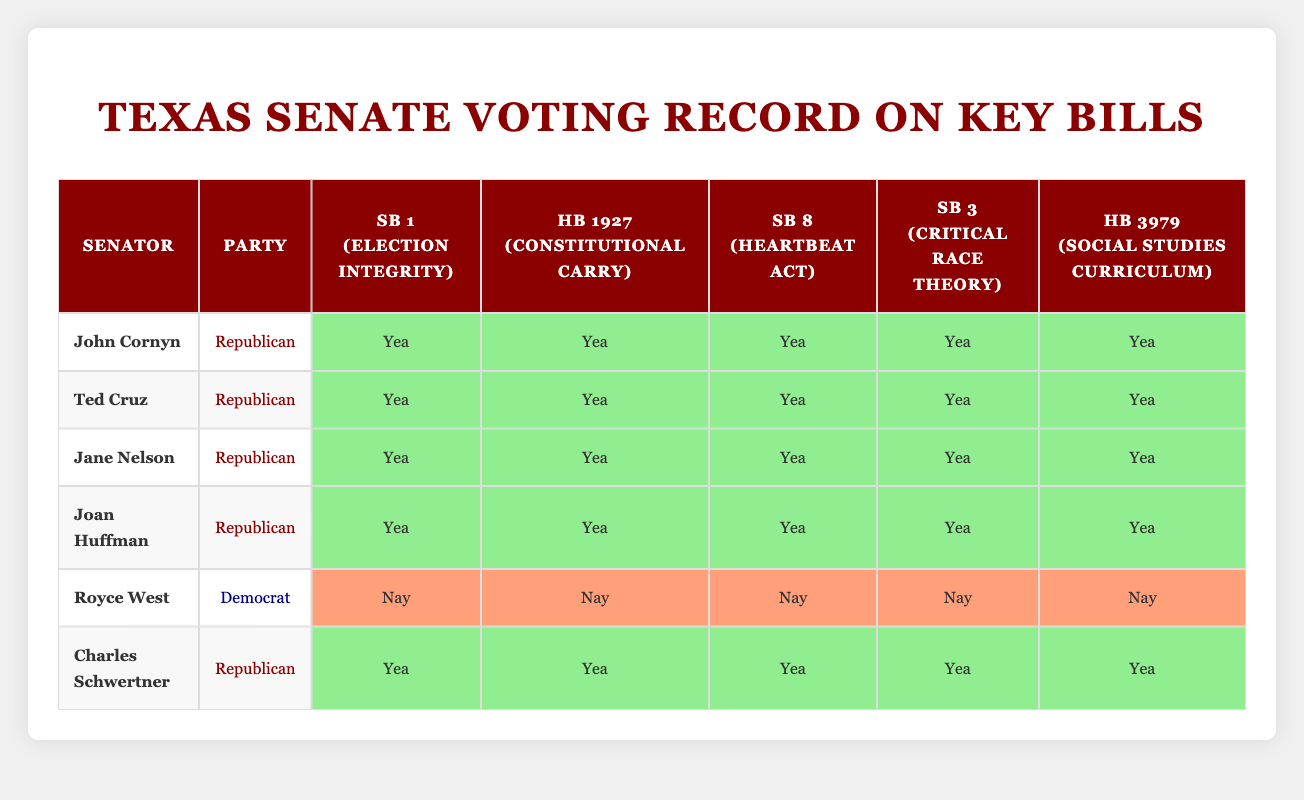What is the party affiliation of Royce West? Royce West is listed in the table, and the corresponding party affiliation column shows "Democrat."
Answer: Democrat How many senators voted "Yea" for HB 1927? In the voting record for HB 1927, I can see John Cornyn, Ted Cruz, Jane Nelson, Joan Huffman, and Charles Schwertner all voted "Yea." Counting these gives 5 senators.
Answer: 5 Did any senator vote "Nay" on SB 3? In the voting record for SB 3, I see that Royce West is the only senator who voted "Nay," while the others all voted "Yea." Therefore, the answer to this question is true as at least one senator voted "Nay."
Answer: Yes Which senator has a voting record of all "Yea" votes? Looking through the voting records, I can identify that John Cornyn, Ted Cruz, Jane Nelson, Joan Huffman, and Charles Schwertner all voted "Yea" on each bill. For a complete "Yea" record, any of these senators qualifies, but for the simplest answer, I can just choose one, like John Cornyn.
Answer: John Cornyn If we average the number of "Yea" votes per senator, what do we get? Each senator voted on 5 bills. Since 5 senators voted "Yea" on all 5 bills and 1 senator voted "Yea" on none, we sum the "Yea" votes: (5 votes per senator * 5 senators) = 25 total "Yea" votes. Then for the average, we divide by the total number of senators (6): 25 / 6 = 4.17.
Answer: 4.17 